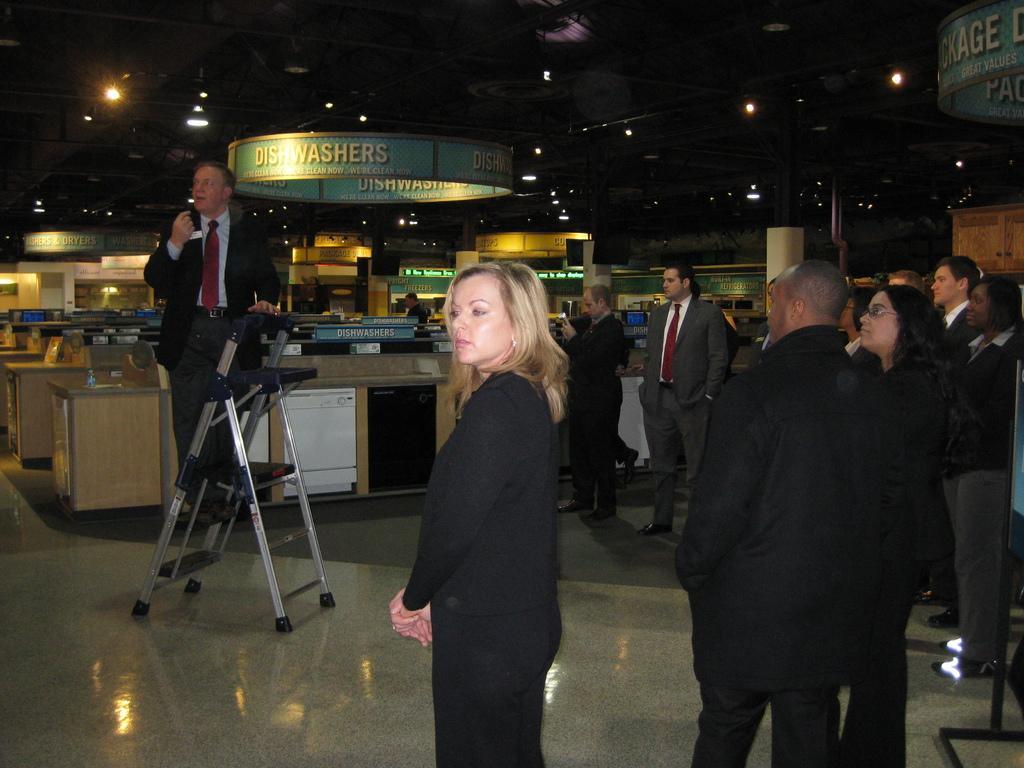Can you describe this image briefly? In this image I can see few persons wearing black colored dresses are standing on the ground and another person standing on the ladder. In the background I can see few wooden desks, few boards, the ceiling and few lights to the ceiling. 